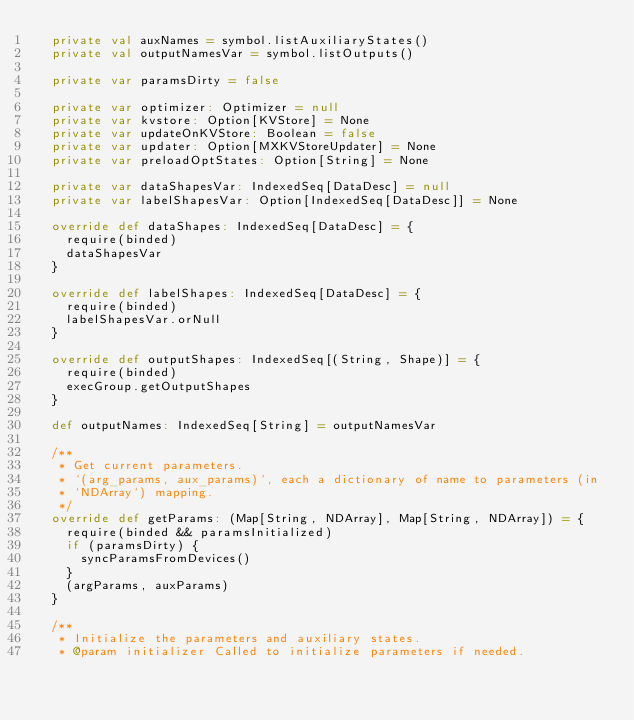Convert code to text. <code><loc_0><loc_0><loc_500><loc_500><_Scala_>  private val auxNames = symbol.listAuxiliaryStates()
  private val outputNamesVar = symbol.listOutputs()

  private var paramsDirty = false

  private var optimizer: Optimizer = null
  private var kvstore: Option[KVStore] = None
  private var updateOnKVStore: Boolean = false
  private var updater: Option[MXKVStoreUpdater] = None
  private var preloadOptStates: Option[String] = None

  private var dataShapesVar: IndexedSeq[DataDesc] = null
  private var labelShapesVar: Option[IndexedSeq[DataDesc]] = None

  override def dataShapes: IndexedSeq[DataDesc] = {
    require(binded)
    dataShapesVar
  }

  override def labelShapes: IndexedSeq[DataDesc] = {
    require(binded)
    labelShapesVar.orNull
  }

  override def outputShapes: IndexedSeq[(String, Shape)] = {
    require(binded)
    execGroup.getOutputShapes
  }

  def outputNames: IndexedSeq[String] = outputNamesVar

  /**
   * Get current parameters.
   * `(arg_params, aux_params)`, each a dictionary of name to parameters (in
   * `NDArray`) mapping.
   */
  override def getParams: (Map[String, NDArray], Map[String, NDArray]) = {
    require(binded && paramsInitialized)
    if (paramsDirty) {
      syncParamsFromDevices()
    }
    (argParams, auxParams)
  }

  /**
   * Initialize the parameters and auxiliary states.
   * @param initializer Called to initialize parameters if needed.</code> 